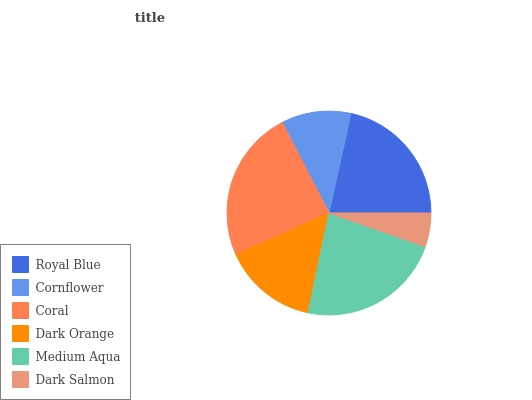Is Dark Salmon the minimum?
Answer yes or no. Yes. Is Coral the maximum?
Answer yes or no. Yes. Is Cornflower the minimum?
Answer yes or no. No. Is Cornflower the maximum?
Answer yes or no. No. Is Royal Blue greater than Cornflower?
Answer yes or no. Yes. Is Cornflower less than Royal Blue?
Answer yes or no. Yes. Is Cornflower greater than Royal Blue?
Answer yes or no. No. Is Royal Blue less than Cornflower?
Answer yes or no. No. Is Royal Blue the high median?
Answer yes or no. Yes. Is Dark Orange the low median?
Answer yes or no. Yes. Is Dark Salmon the high median?
Answer yes or no. No. Is Cornflower the low median?
Answer yes or no. No. 